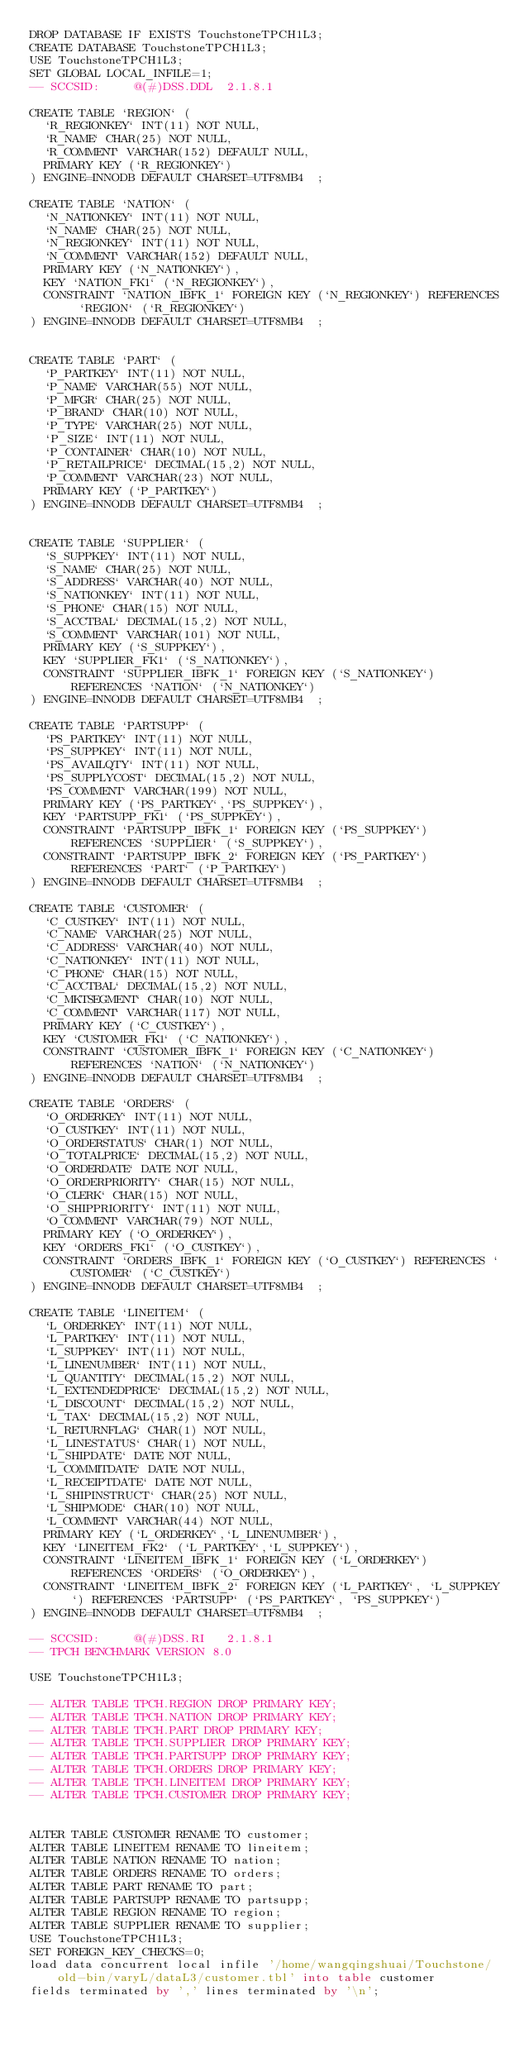<code> <loc_0><loc_0><loc_500><loc_500><_SQL_>DROP DATABASE IF EXISTS TouchstoneTPCH1L3;
CREATE DATABASE TouchstoneTPCH1L3;
USE TouchstoneTPCH1L3;
SET GLOBAL LOCAL_INFILE=1;
-- SCCSID:     @(#)DSS.DDL	2.1.8.1

CREATE TABLE `REGION` (
  `R_REGIONKEY` INT(11) NOT NULL,
  `R_NAME` CHAR(25) NOT NULL,
  `R_COMMENT` VARCHAR(152) DEFAULT NULL,
  PRIMARY KEY (`R_REGIONKEY`)
) ENGINE=INNODB DEFAULT CHARSET=UTF8MB4  ;

CREATE TABLE `NATION` (
  `N_NATIONKEY` INT(11) NOT NULL,
  `N_NAME` CHAR(25) NOT NULL,
  `N_REGIONKEY` INT(11) NOT NULL,
  `N_COMMENT` VARCHAR(152) DEFAULT NULL,
  PRIMARY KEY (`N_NATIONKEY`),
  KEY `NATION_FK1` (`N_REGIONKEY`),
  CONSTRAINT `NATION_IBFK_1` FOREIGN KEY (`N_REGIONKEY`) REFERENCES `REGION` (`R_REGIONKEY`)
) ENGINE=INNODB DEFAULT CHARSET=UTF8MB4  ;


CREATE TABLE `PART` (
  `P_PARTKEY` INT(11) NOT NULL,
  `P_NAME` VARCHAR(55) NOT NULL,
  `P_MFGR` CHAR(25) NOT NULL,
  `P_BRAND` CHAR(10) NOT NULL,
  `P_TYPE` VARCHAR(25) NOT NULL,
  `P_SIZE` INT(11) NOT NULL,
  `P_CONTAINER` CHAR(10) NOT NULL,
  `P_RETAILPRICE` DECIMAL(15,2) NOT NULL,
  `P_COMMENT` VARCHAR(23) NOT NULL,
  PRIMARY KEY (`P_PARTKEY`)
) ENGINE=INNODB DEFAULT CHARSET=UTF8MB4  ;


CREATE TABLE `SUPPLIER` (
  `S_SUPPKEY` INT(11) NOT NULL,
  `S_NAME` CHAR(25) NOT NULL,
  `S_ADDRESS` VARCHAR(40) NOT NULL,
  `S_NATIONKEY` INT(11) NOT NULL,
  `S_PHONE` CHAR(15) NOT NULL,
  `S_ACCTBAL` DECIMAL(15,2) NOT NULL,
  `S_COMMENT` VARCHAR(101) NOT NULL,
  PRIMARY KEY (`S_SUPPKEY`),
  KEY `SUPPLIER_FK1` (`S_NATIONKEY`),
  CONSTRAINT `SUPPLIER_IBFK_1` FOREIGN KEY (`S_NATIONKEY`) REFERENCES `NATION` (`N_NATIONKEY`)
) ENGINE=INNODB DEFAULT CHARSET=UTF8MB4  ;

CREATE TABLE `PARTSUPP` (
  `PS_PARTKEY` INT(11) NOT NULL,
  `PS_SUPPKEY` INT(11) NOT NULL,
  `PS_AVAILQTY` INT(11) NOT NULL,
  `PS_SUPPLYCOST` DECIMAL(15,2) NOT NULL,
  `PS_COMMENT` VARCHAR(199) NOT NULL,
  PRIMARY KEY (`PS_PARTKEY`,`PS_SUPPKEY`),
  KEY `PARTSUPP_FK1` (`PS_SUPPKEY`),
  CONSTRAINT `PARTSUPP_IBFK_1` FOREIGN KEY (`PS_SUPPKEY`) REFERENCES `SUPPLIER` (`S_SUPPKEY`),
  CONSTRAINT `PARTSUPP_IBFK_2` FOREIGN KEY (`PS_PARTKEY`) REFERENCES `PART` (`P_PARTKEY`)
) ENGINE=INNODB DEFAULT CHARSET=UTF8MB4  ;

CREATE TABLE `CUSTOMER` (
  `C_CUSTKEY` INT(11) NOT NULL,
  `C_NAME` VARCHAR(25) NOT NULL,
  `C_ADDRESS` VARCHAR(40) NOT NULL,
  `C_NATIONKEY` INT(11) NOT NULL,
  `C_PHONE` CHAR(15) NOT NULL,
  `C_ACCTBAL` DECIMAL(15,2) NOT NULL,
  `C_MKTSEGMENT` CHAR(10) NOT NULL,
  `C_COMMENT` VARCHAR(117) NOT NULL,
  PRIMARY KEY (`C_CUSTKEY`),
  KEY `CUSTOMER_FK1` (`C_NATIONKEY`),
  CONSTRAINT `CUSTOMER_IBFK_1` FOREIGN KEY (`C_NATIONKEY`) REFERENCES `NATION` (`N_NATIONKEY`)
) ENGINE=INNODB DEFAULT CHARSET=UTF8MB4  ;

CREATE TABLE `ORDERS` (
  `O_ORDERKEY` INT(11) NOT NULL,
  `O_CUSTKEY` INT(11) NOT NULL,
  `O_ORDERSTATUS` CHAR(1) NOT NULL,
  `O_TOTALPRICE` DECIMAL(15,2) NOT NULL,
  `O_ORDERDATE` DATE NOT NULL,
  `O_ORDERPRIORITY` CHAR(15) NOT NULL,
  `O_CLERK` CHAR(15) NOT NULL,
  `O_SHIPPRIORITY` INT(11) NOT NULL,
  `O_COMMENT` VARCHAR(79) NOT NULL,
  PRIMARY KEY (`O_ORDERKEY`),
  KEY `ORDERS_FK1` (`O_CUSTKEY`),
  CONSTRAINT `ORDERS_IBFK_1` FOREIGN KEY (`O_CUSTKEY`) REFERENCES `CUSTOMER` (`C_CUSTKEY`)
) ENGINE=INNODB DEFAULT CHARSET=UTF8MB4  ;

CREATE TABLE `LINEITEM` (
  `L_ORDERKEY` INT(11) NOT NULL,
  `L_PARTKEY` INT(11) NOT NULL,
  `L_SUPPKEY` INT(11) NOT NULL,
  `L_LINENUMBER` INT(11) NOT NULL,
  `L_QUANTITY` DECIMAL(15,2) NOT NULL,
  `L_EXTENDEDPRICE` DECIMAL(15,2) NOT NULL,
  `L_DISCOUNT` DECIMAL(15,2) NOT NULL,
  `L_TAX` DECIMAL(15,2) NOT NULL,
  `L_RETURNFLAG` CHAR(1) NOT NULL,
  `L_LINESTATUS` CHAR(1) NOT NULL,
  `L_SHIPDATE` DATE NOT NULL,
  `L_COMMITDATE` DATE NOT NULL,
  `L_RECEIPTDATE` DATE NOT NULL,
  `L_SHIPINSTRUCT` CHAR(25) NOT NULL,
  `L_SHIPMODE` CHAR(10) NOT NULL,
  `L_COMMENT` VARCHAR(44) NOT NULL,
  PRIMARY KEY (`L_ORDERKEY`,`L_LINENUMBER`),
  KEY `LINEITEM_FK2` (`L_PARTKEY`,`L_SUPPKEY`),
  CONSTRAINT `LINEITEM_IBFK_1` FOREIGN KEY (`L_ORDERKEY`) REFERENCES `ORDERS` (`O_ORDERKEY`),
  CONSTRAINT `LINEITEM_IBFK_2` FOREIGN KEY (`L_PARTKEY`, `L_SUPPKEY`) REFERENCES `PARTSUPP` (`PS_PARTKEY`, `PS_SUPPKEY`)
) ENGINE=INNODB DEFAULT CHARSET=UTF8MB4  ;

-- SCCSID:     @(#)DSS.RI	2.1.8.1
-- TPCH BENCHMARK VERSION 8.0

USE TouchstoneTPCH1L3;

-- ALTER TABLE TPCH.REGION DROP PRIMARY KEY;
-- ALTER TABLE TPCH.NATION DROP PRIMARY KEY;
-- ALTER TABLE TPCH.PART DROP PRIMARY KEY;
-- ALTER TABLE TPCH.SUPPLIER DROP PRIMARY KEY;
-- ALTER TABLE TPCH.PARTSUPP DROP PRIMARY KEY;
-- ALTER TABLE TPCH.ORDERS DROP PRIMARY KEY;
-- ALTER TABLE TPCH.LINEITEM DROP PRIMARY KEY;
-- ALTER TABLE TPCH.CUSTOMER DROP PRIMARY KEY;


ALTER TABLE CUSTOMER RENAME TO customer;
ALTER TABLE LINEITEM RENAME TO lineitem;
ALTER TABLE NATION RENAME TO nation;
ALTER TABLE ORDERS RENAME TO orders;
ALTER TABLE PART RENAME TO part;
ALTER TABLE PARTSUPP RENAME TO partsupp;
ALTER TABLE REGION RENAME TO region;
ALTER TABLE SUPPLIER RENAME TO supplier;
USE TouchstoneTPCH1L3;
SET FOREIGN_KEY_CHECKS=0;
load data concurrent local infile '/home/wangqingshuai/Touchstone/old-bin/varyL/dataL3/customer.tbl' into table customer
fields terminated by ',' lines terminated by '\n';</code> 